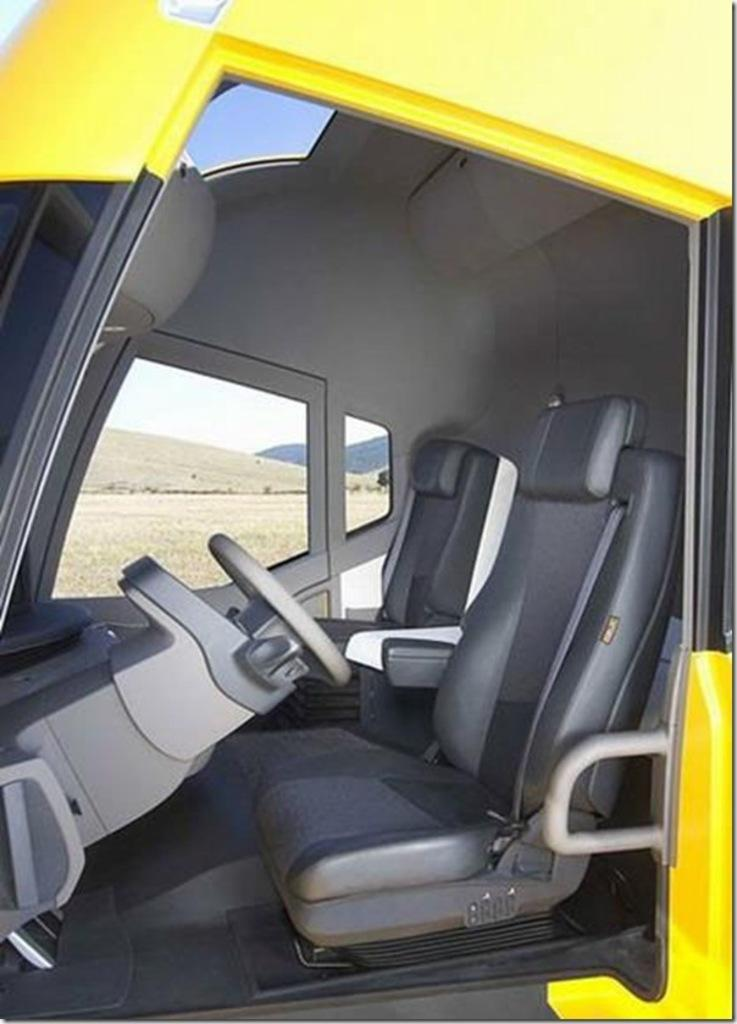What type of setting is depicted in the image? The image shows the inside view of a vehicle. What feature allows the viewer to see outside the vehicle? There is a glass window in the vehicle. What can be seen through the glass window? Hills, the ground, and the sky are visible through the glass window. Can you see a thumbprint on the glass window in the image? There is no mention of a thumbprint on the glass window in the provided facts, so it cannot be determined from the image. --- Facts: 1. There is a person sitting on a chair in the image. 2. The person is holding a book. 3. The book has a blue cover. 4. There is a table next to the chair. 5. A lamp is on the table. Absurd Topics: elephant, ocean, dance Conversation: What is the person in the image doing? The person is sitting on a chair in the image. What object is the person holding? The person is holding a book. What color is the book's cover? The book has a blue cover. What is located next to the chair? There is a table next to the chair. What is on the table? A lamp is on the table. Reasoning: Let's think step by step in order to produce the conversation. We start by identifying the main subject in the image, which is the person sitting on a chair. Then, we describe what the person is doing, which is holding a book. Next, we provide details about the book, such as its color. Finally, we mention the table and lamp, which are additional objects in the image. Absurd Question/Answer: Can you see an elephant swimming in the ocean in the image? There is no mention of an elephant or an ocean in the provided facts, so it cannot be determined from the image. 